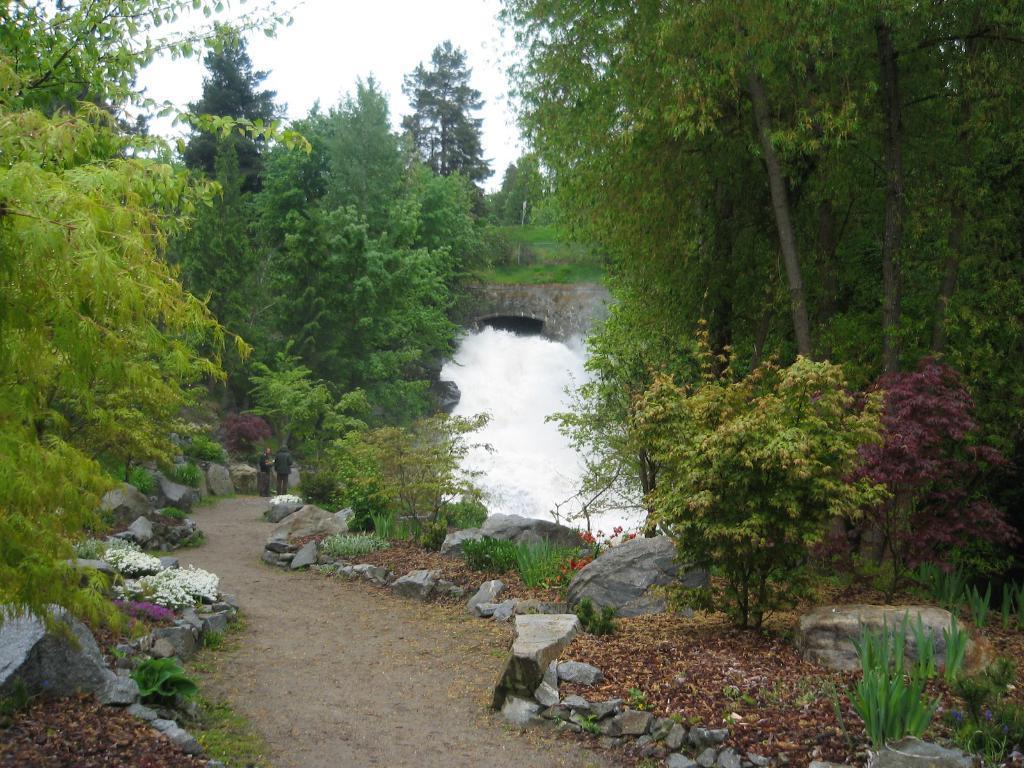How would you summarize this image in a sentence or two? In this picture we can see two people on the path, beside this path we can see some stones, plants and in the background we can see trees, sky. 